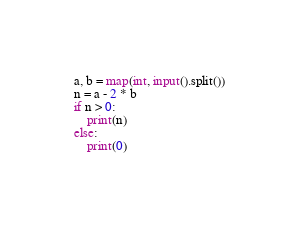Convert code to text. <code><loc_0><loc_0><loc_500><loc_500><_Python_>a, b = map(int, input().split())
n = a - 2 * b
if n > 0:
    print(n)
else:
    print(0)
</code> 